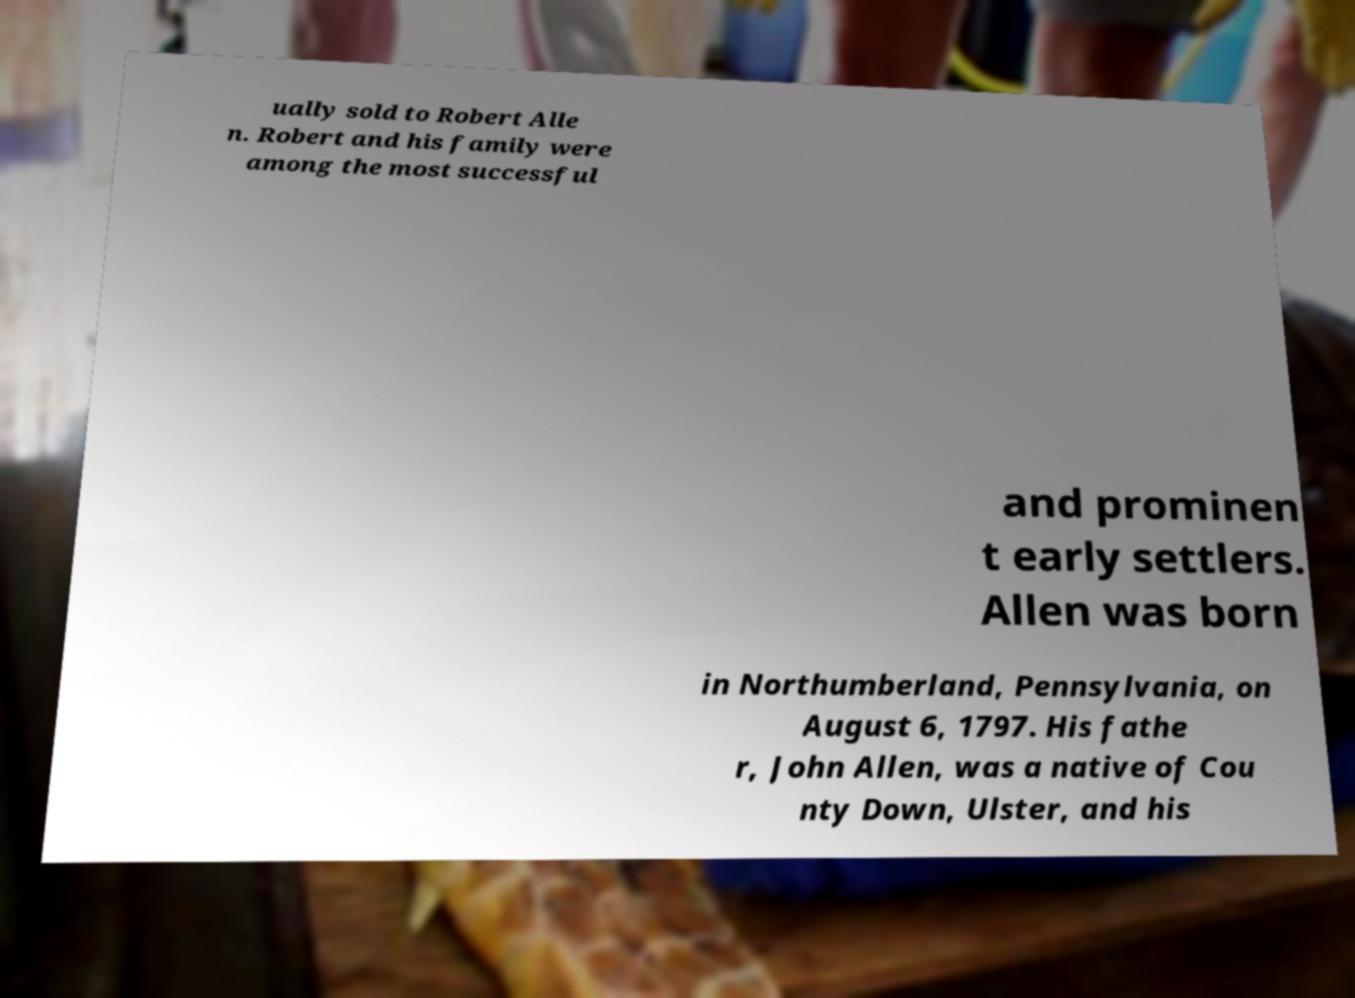I need the written content from this picture converted into text. Can you do that? ually sold to Robert Alle n. Robert and his family were among the most successful and prominen t early settlers. Allen was born in Northumberland, Pennsylvania, on August 6, 1797. His fathe r, John Allen, was a native of Cou nty Down, Ulster, and his 